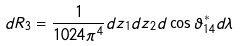<formula> <loc_0><loc_0><loc_500><loc_500>d R _ { 3 } = \frac { 1 } { 1 0 2 4 \pi ^ { 4 } } d z _ { 1 } d z _ { 2 } d \cos \vartheta _ { 1 4 } ^ { * } d \lambda</formula> 